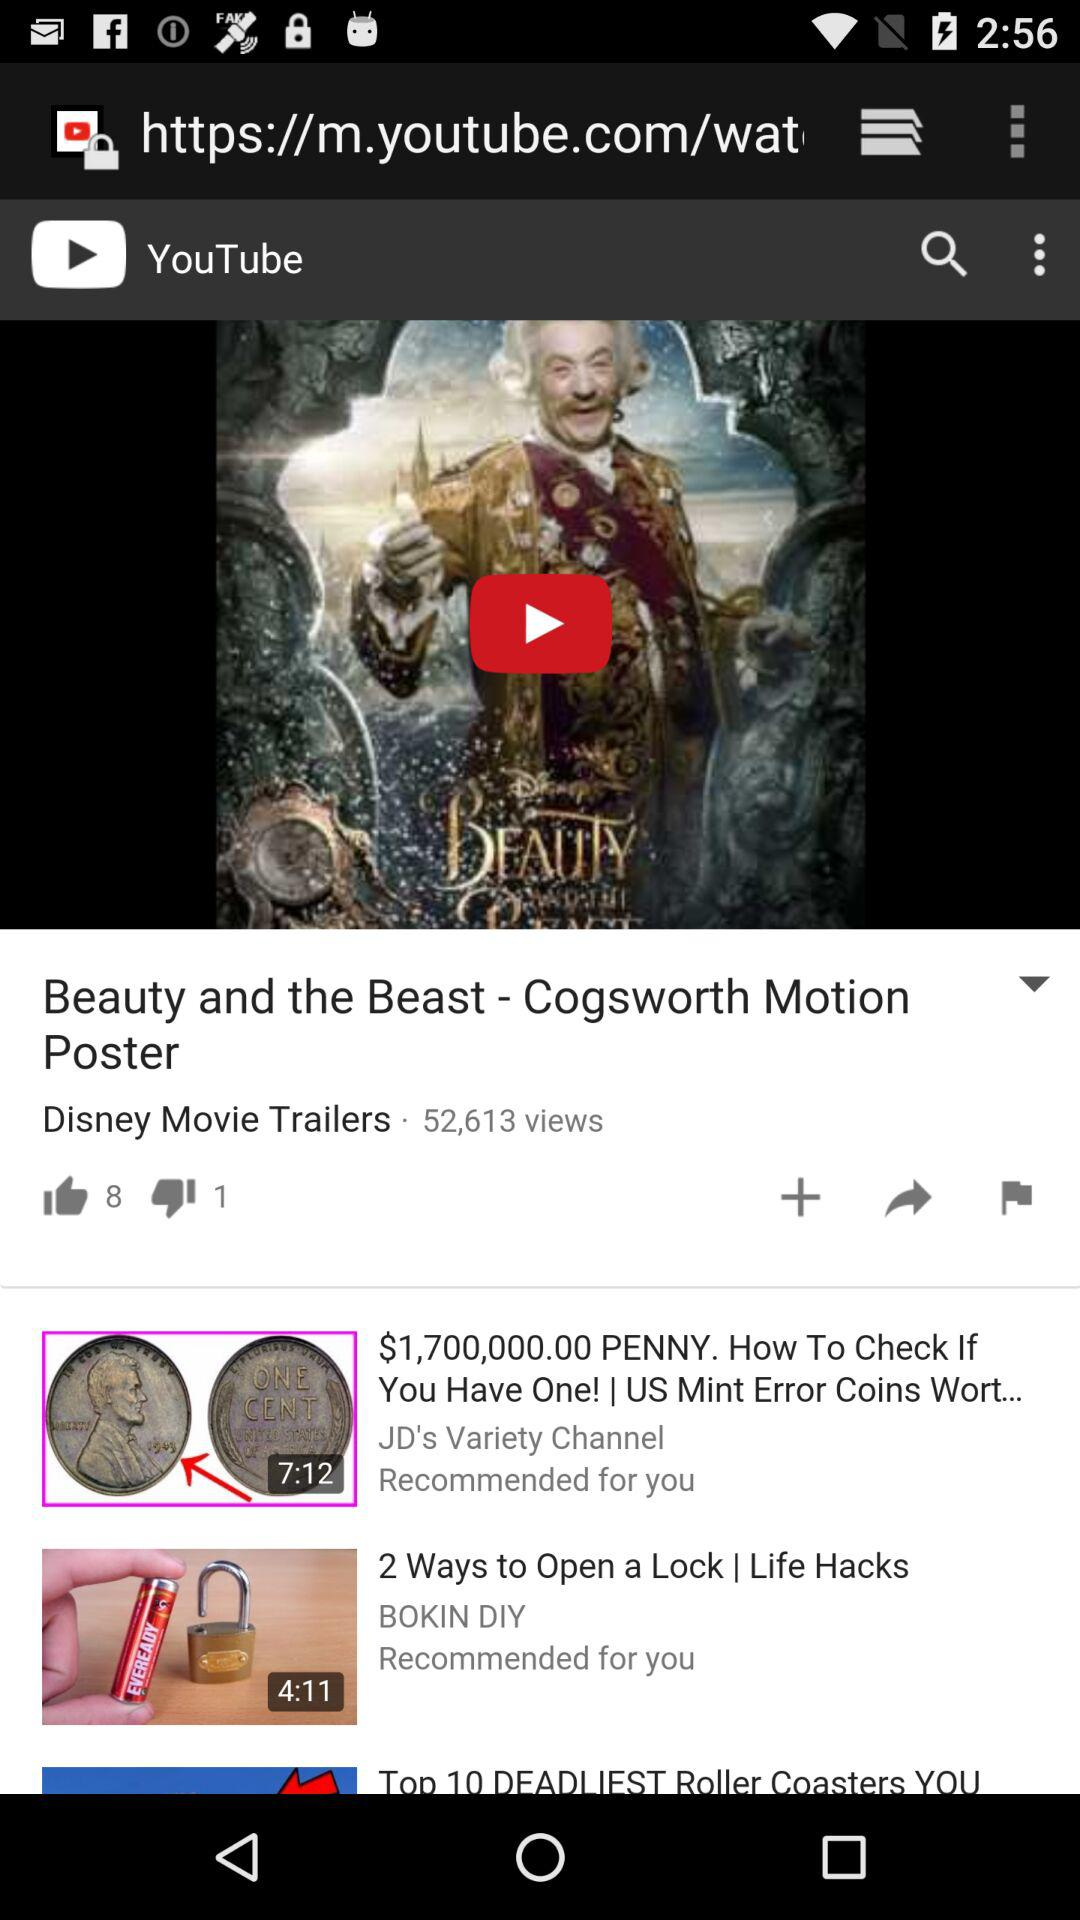How many people disliked the video? There is 1 person who disliked the video. 